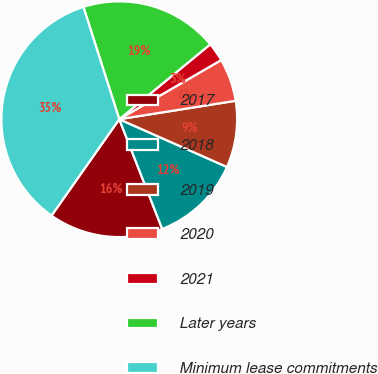Convert chart. <chart><loc_0><loc_0><loc_500><loc_500><pie_chart><fcel>2017<fcel>2018<fcel>2019<fcel>2020<fcel>2021<fcel>Later years<fcel>Minimum lease commitments<nl><fcel>15.69%<fcel>12.42%<fcel>9.14%<fcel>5.87%<fcel>2.59%<fcel>18.96%<fcel>35.33%<nl></chart> 